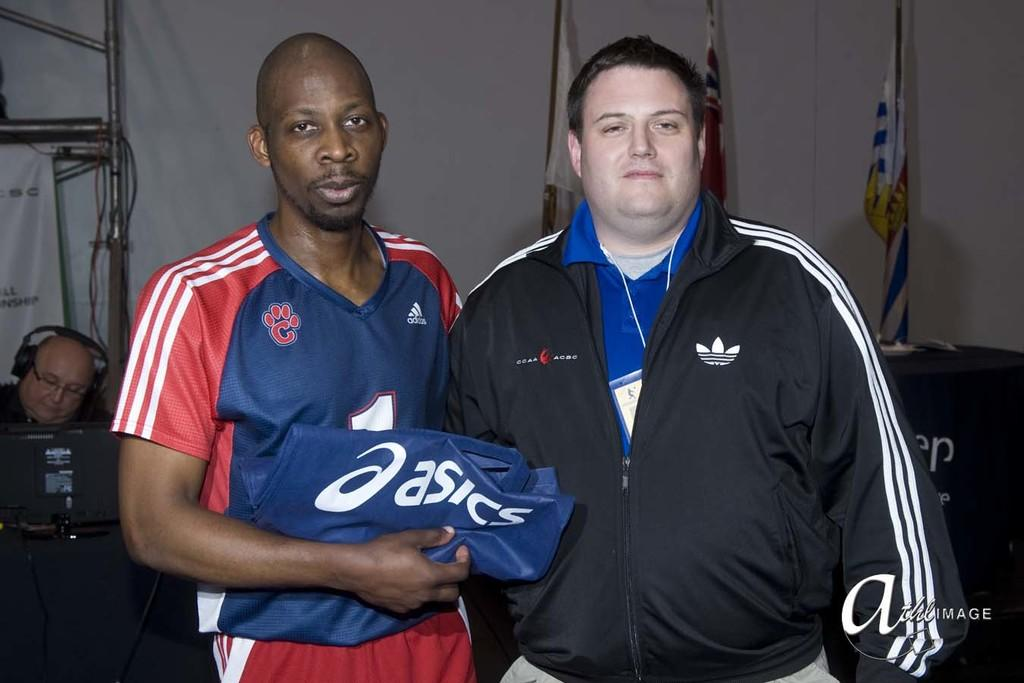Provide a one-sentence caption for the provided image. A man wearing a blue and red jersey holding a folded Asics cloth next to a chubby fellow with a black Adidas jacket. 